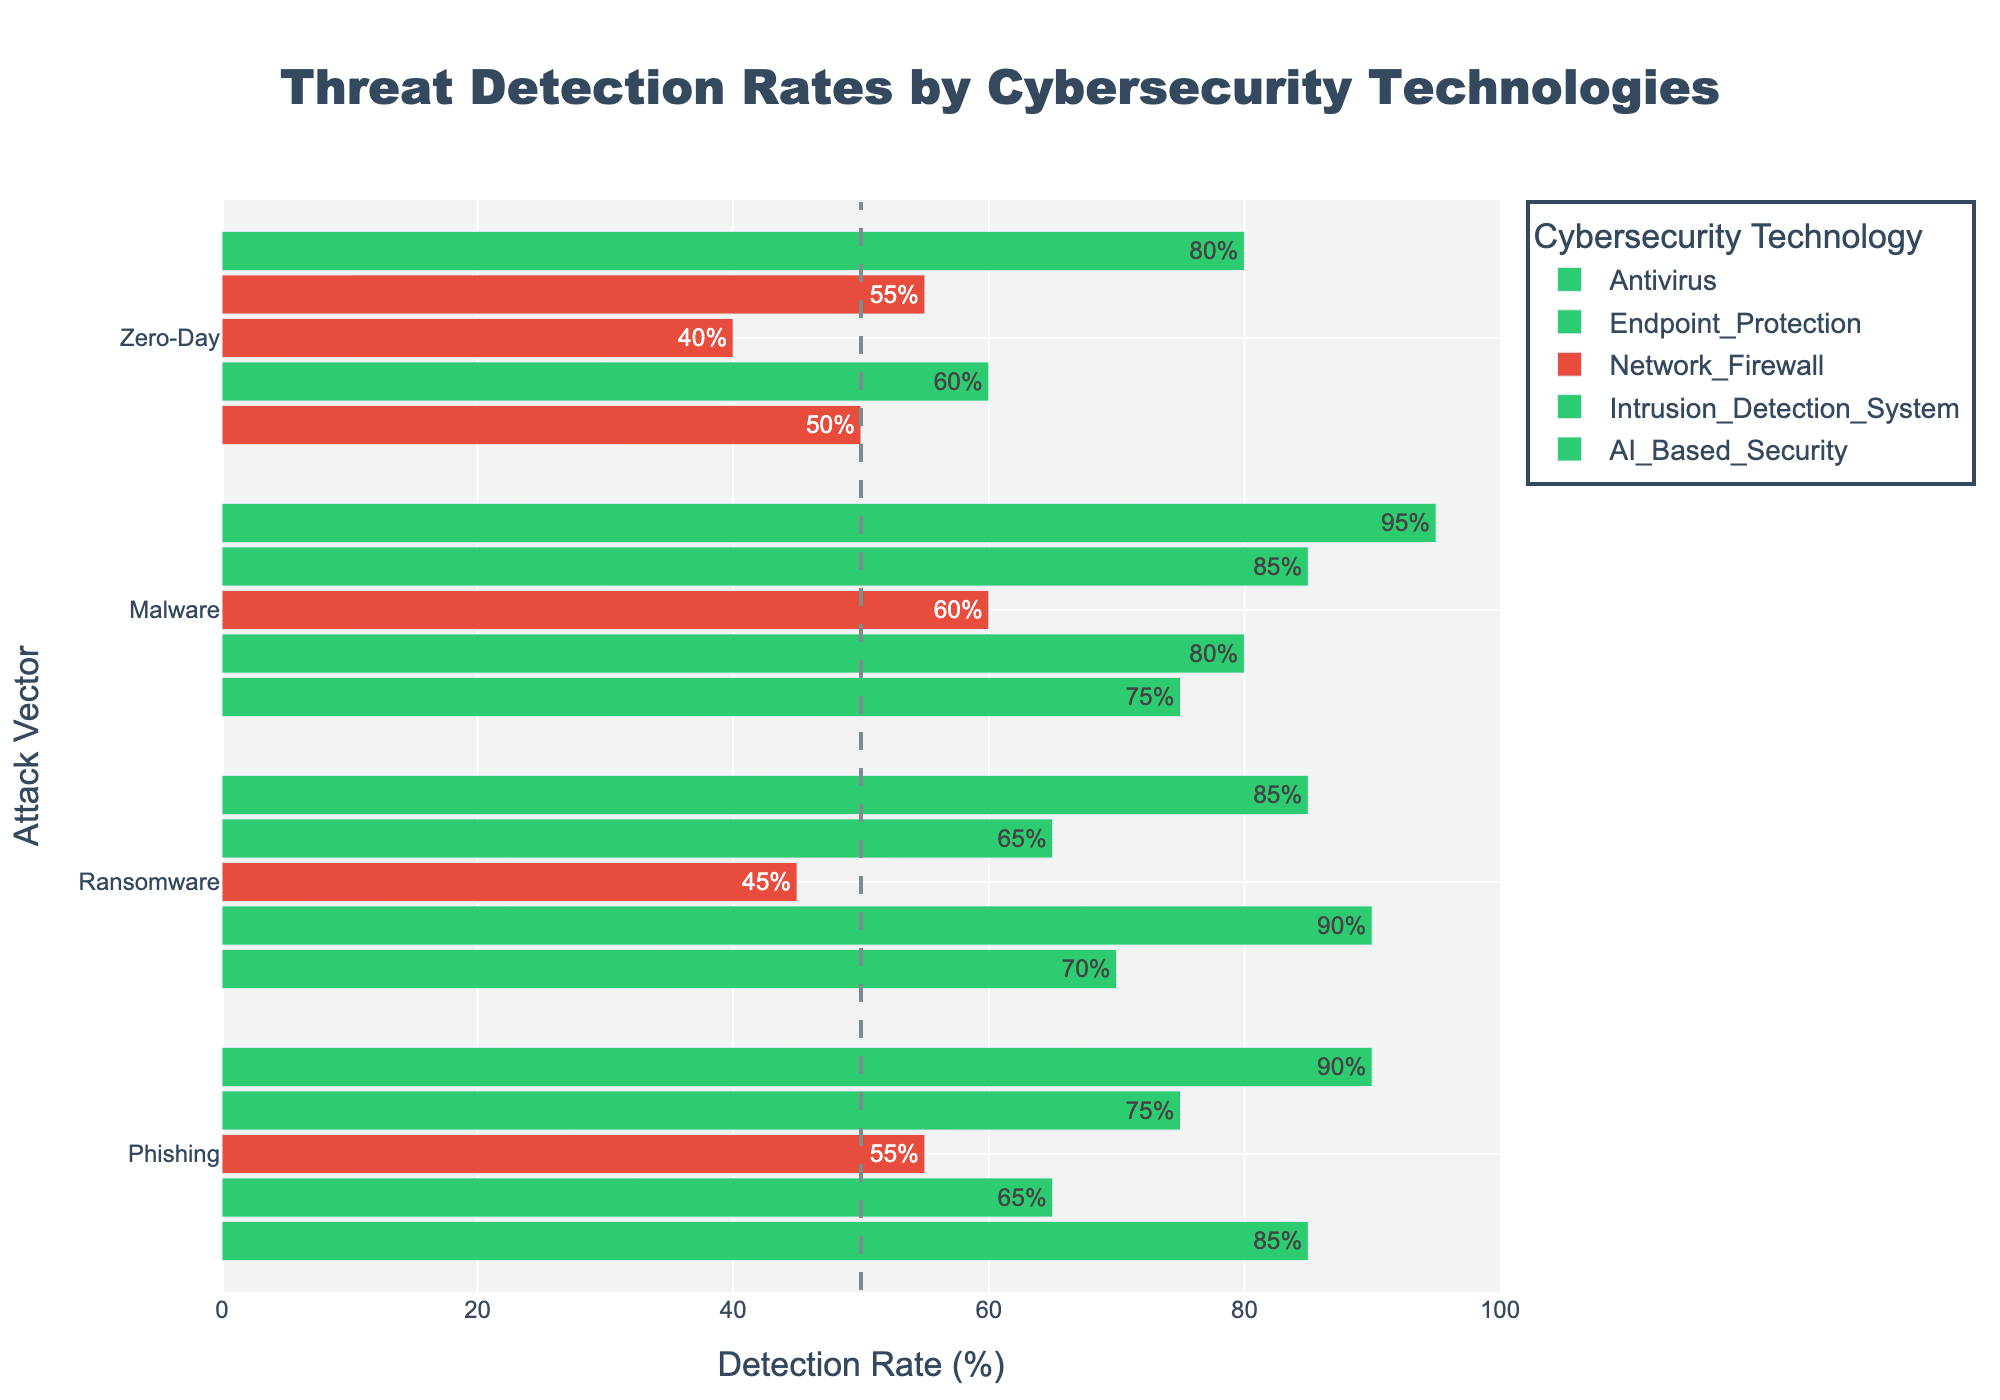Which technology has the highest detection rate for Phishing attacks? The bar corresponding to AI-Based Security has the highest value for Phishing attacks, reaching 90% compared to other technologies.
Answer: AI-Based Security Which attack vector does Antivirus have the lowest detection rate for? The bar for Zero-Day attacks under Antivirus is the lowest among the others and it's marked as 50%, lower than for Ransomware, Phishing, and Malware.
Answer: Zero-Day What's the average detection rate of Endpoint Protection for all attack vectors? Summing the detection rates for Endpoint Protection (Phishing: 65, Ransomware: 90, Malware: 80, Zero-Day: 60) gives 295. Dividing this by the number of attack vectors (4) gives 295/4 = 73.75.
Answer: 73.75% Which technology has the most consistently high detection rates across all attack vectors? Reviewing each technology, AI-Based Security maintains high rates across all vectors: 90 (Phishing), 85 (Ransomware), 95 (Malware), 80 (Zero-Day), which are all well above 50%.
Answer: AI-Based Security For which attack vector does Network Firewall have the highest detection rate? The bar for Malware under Network Firewall is the highest among the vector values for Network Firewall, reaching 60%.
Answer: Malware How many technologies have a positive detection rate for Ransomware above 70%? Antivirus (70), Endpoint Protection (90), AI-Based Security (85) have positive rates above 70% for Ransomware.
Answer: 3 What is the difference in the detection rate for Zero-Day attacks between Intrusion Detection System and AI-Based Security? AI-Based Security for Zero-Day stands at 80% and Intrusion Detection System at 55%. Subtracting these gives 80 - 55 = 25%.
Answer: 25% Which attack vector has the most technologies with a negative detection rate? Reviewing the visually marked bars, Phishing (Antivirus, Network Firewall) and Zero-Day (Antivirus, Network Firewall, Intrusion Detection System) show negative values. Zero-Day has the most with 3.
Answer: Zero-Day Compare the detection rates of Endpoint Protection and Intrusion Detection System for Malware attacks. Which is higher? Endpoint Protection has a detection rate of 80% for Malware while Intrusion Detection System has 85%. Intrusion Detection System's rate is higher.
Answer: Intrusion Detection System What is the combined detection rate for AI-Based Security across all four attack vectors? Adding the detection rates for AI-Based Security (Phishing: 90, Ransomware: 85, Malware: 95, Zero-Day: 80) results in 90 + 85 + 95 + 80 = 350%.
Answer: 350% 